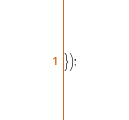Convert code to text. <code><loc_0><loc_0><loc_500><loc_500><_JavaScript_>});</code> 